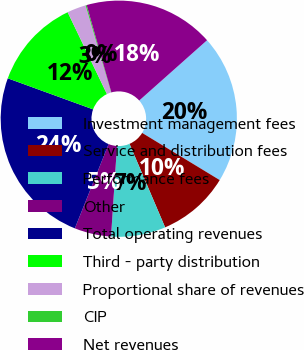Convert chart. <chart><loc_0><loc_0><loc_500><loc_500><pie_chart><fcel>Investment management fees<fcel>Service and distribution fees<fcel>Performance fees<fcel>Other<fcel>Total operating revenues<fcel>Third - party distribution<fcel>Proportional share of revenues<fcel>CIP<fcel>Net revenues<nl><fcel>20.26%<fcel>9.89%<fcel>7.46%<fcel>5.02%<fcel>24.49%<fcel>12.32%<fcel>2.59%<fcel>0.15%<fcel>17.82%<nl></chart> 